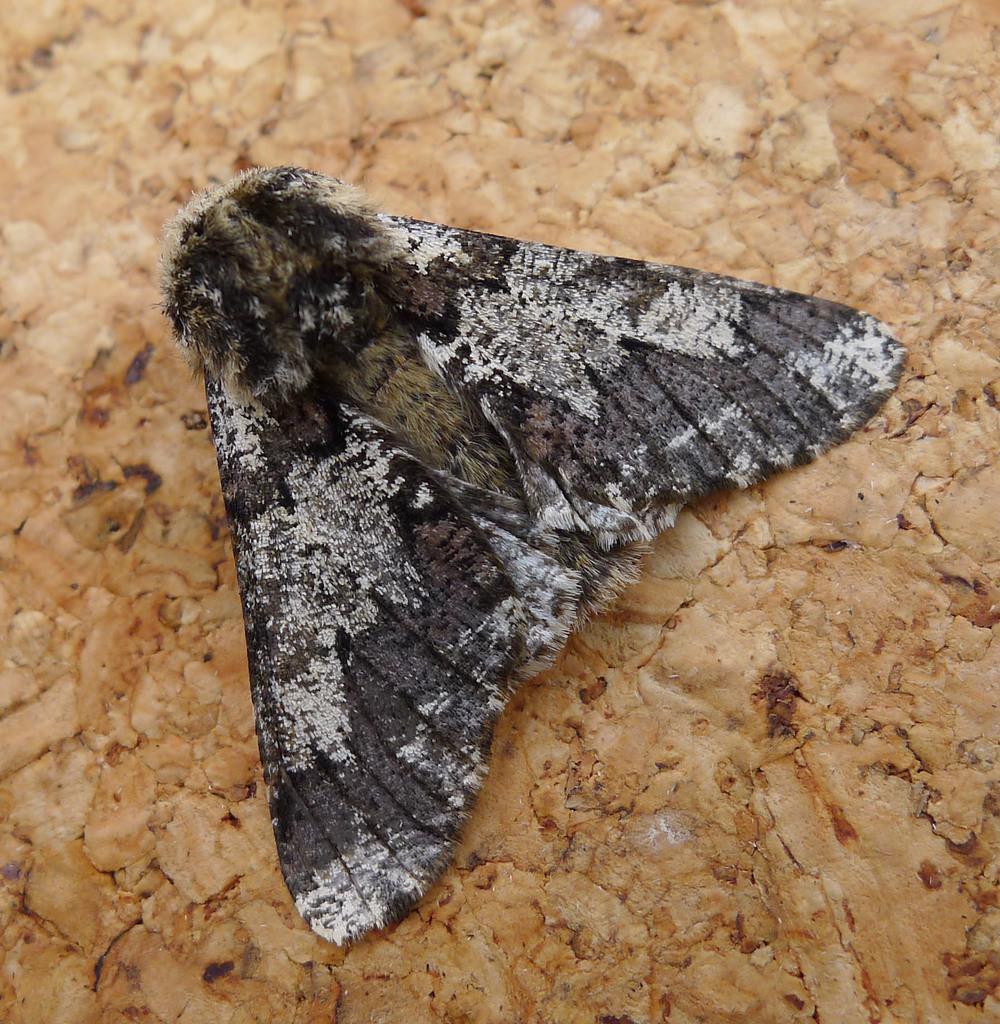Can you describe this image briefly? In this image we can see a fly on the wooden surface. 